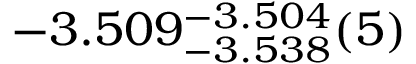Convert formula to latex. <formula><loc_0><loc_0><loc_500><loc_500>- 3 . 5 0 9 _ { - 3 . 5 3 8 } ^ { - 3 . 5 0 4 } ( 5 )</formula> 